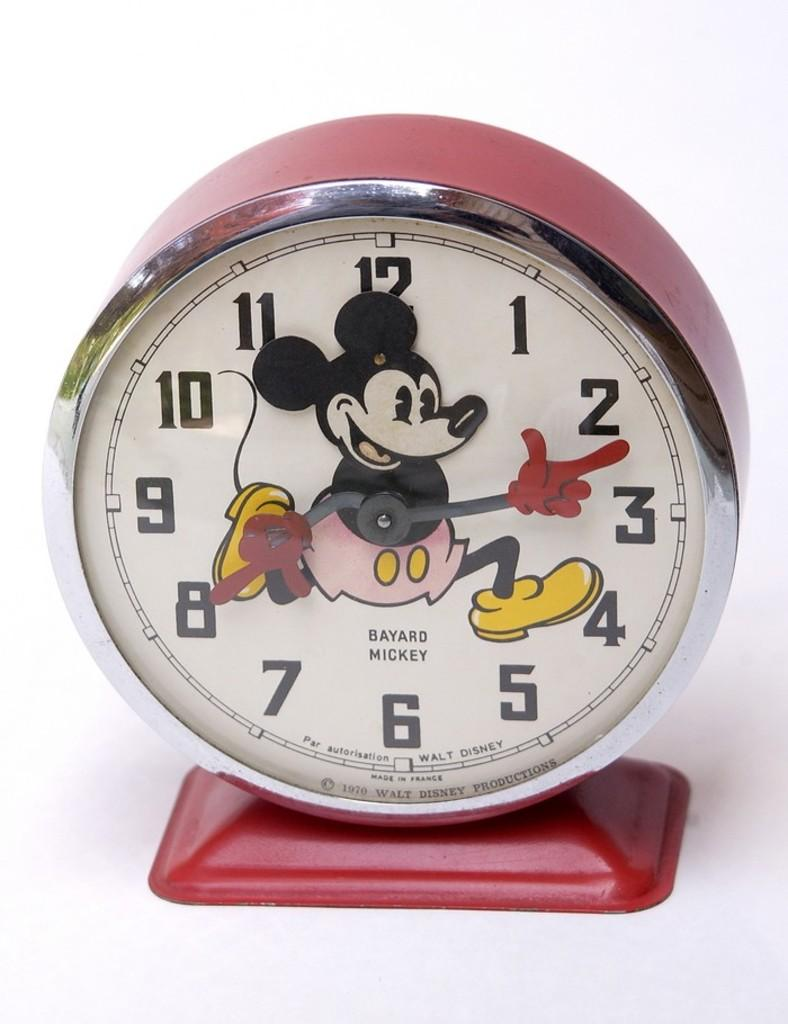<image>
Provide a brief description of the given image. A red Bayard Mickey clock featuring Mickey mouse. 